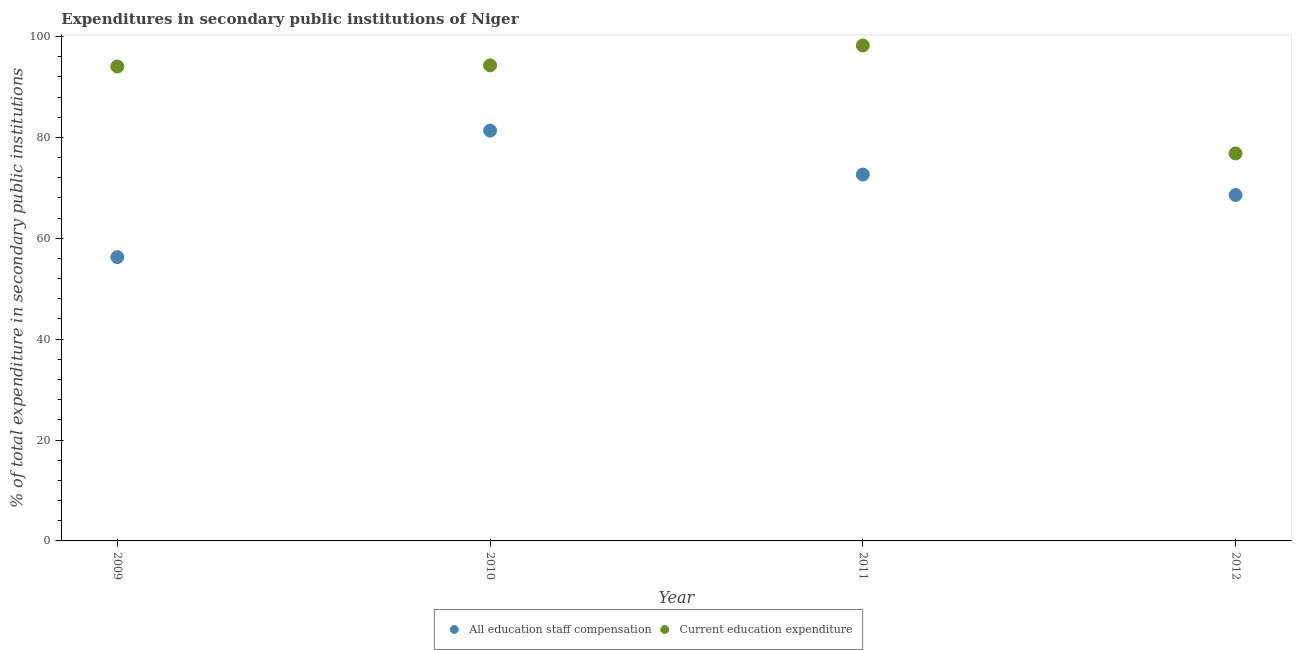How many different coloured dotlines are there?
Offer a terse response. 2. What is the expenditure in education in 2010?
Keep it short and to the point. 94.28. Across all years, what is the maximum expenditure in staff compensation?
Ensure brevity in your answer.  81.35. Across all years, what is the minimum expenditure in education?
Your answer should be compact. 76.82. In which year was the expenditure in education maximum?
Offer a very short reply. 2011. What is the total expenditure in education in the graph?
Ensure brevity in your answer.  363.37. What is the difference between the expenditure in staff compensation in 2009 and that in 2011?
Your answer should be very brief. -16.37. What is the difference between the expenditure in education in 2011 and the expenditure in staff compensation in 2009?
Your answer should be very brief. 41.96. What is the average expenditure in staff compensation per year?
Your answer should be compact. 69.7. In the year 2009, what is the difference between the expenditure in staff compensation and expenditure in education?
Keep it short and to the point. -37.79. In how many years, is the expenditure in education greater than 36 %?
Give a very brief answer. 4. What is the ratio of the expenditure in education in 2011 to that in 2012?
Give a very brief answer. 1.28. Is the expenditure in education in 2009 less than that in 2012?
Your answer should be compact. No. Is the difference between the expenditure in education in 2009 and 2012 greater than the difference between the expenditure in staff compensation in 2009 and 2012?
Make the answer very short. Yes. What is the difference between the highest and the second highest expenditure in education?
Give a very brief answer. 3.94. What is the difference between the highest and the lowest expenditure in education?
Your answer should be very brief. 21.4. In how many years, is the expenditure in staff compensation greater than the average expenditure in staff compensation taken over all years?
Offer a very short reply. 2. Is the sum of the expenditure in education in 2009 and 2011 greater than the maximum expenditure in staff compensation across all years?
Keep it short and to the point. Yes. How many years are there in the graph?
Your answer should be compact. 4. What is the difference between two consecutive major ticks on the Y-axis?
Your answer should be compact. 20. Where does the legend appear in the graph?
Offer a terse response. Bottom center. How many legend labels are there?
Give a very brief answer. 2. How are the legend labels stacked?
Provide a short and direct response. Horizontal. What is the title of the graph?
Your response must be concise. Expenditures in secondary public institutions of Niger. Does "Money lenders" appear as one of the legend labels in the graph?
Keep it short and to the point. No. What is the label or title of the Y-axis?
Offer a terse response. % of total expenditure in secondary public institutions. What is the % of total expenditure in secondary public institutions in All education staff compensation in 2009?
Give a very brief answer. 56.26. What is the % of total expenditure in secondary public institutions in Current education expenditure in 2009?
Provide a short and direct response. 94.05. What is the % of total expenditure in secondary public institutions in All education staff compensation in 2010?
Offer a terse response. 81.35. What is the % of total expenditure in secondary public institutions in Current education expenditure in 2010?
Your answer should be very brief. 94.28. What is the % of total expenditure in secondary public institutions in All education staff compensation in 2011?
Offer a very short reply. 72.63. What is the % of total expenditure in secondary public institutions of Current education expenditure in 2011?
Make the answer very short. 98.22. What is the % of total expenditure in secondary public institutions of All education staff compensation in 2012?
Your answer should be very brief. 68.58. What is the % of total expenditure in secondary public institutions in Current education expenditure in 2012?
Provide a succinct answer. 76.82. Across all years, what is the maximum % of total expenditure in secondary public institutions of All education staff compensation?
Ensure brevity in your answer.  81.35. Across all years, what is the maximum % of total expenditure in secondary public institutions of Current education expenditure?
Offer a very short reply. 98.22. Across all years, what is the minimum % of total expenditure in secondary public institutions of All education staff compensation?
Ensure brevity in your answer.  56.26. Across all years, what is the minimum % of total expenditure in secondary public institutions in Current education expenditure?
Give a very brief answer. 76.82. What is the total % of total expenditure in secondary public institutions in All education staff compensation in the graph?
Make the answer very short. 278.82. What is the total % of total expenditure in secondary public institutions in Current education expenditure in the graph?
Provide a short and direct response. 363.37. What is the difference between the % of total expenditure in secondary public institutions of All education staff compensation in 2009 and that in 2010?
Your answer should be compact. -25.09. What is the difference between the % of total expenditure in secondary public institutions in Current education expenditure in 2009 and that in 2010?
Provide a short and direct response. -0.22. What is the difference between the % of total expenditure in secondary public institutions of All education staff compensation in 2009 and that in 2011?
Make the answer very short. -16.37. What is the difference between the % of total expenditure in secondary public institutions of Current education expenditure in 2009 and that in 2011?
Provide a short and direct response. -4.17. What is the difference between the % of total expenditure in secondary public institutions of All education staff compensation in 2009 and that in 2012?
Provide a short and direct response. -12.32. What is the difference between the % of total expenditure in secondary public institutions of Current education expenditure in 2009 and that in 2012?
Offer a very short reply. 17.24. What is the difference between the % of total expenditure in secondary public institutions of All education staff compensation in 2010 and that in 2011?
Make the answer very short. 8.72. What is the difference between the % of total expenditure in secondary public institutions in Current education expenditure in 2010 and that in 2011?
Offer a very short reply. -3.94. What is the difference between the % of total expenditure in secondary public institutions of All education staff compensation in 2010 and that in 2012?
Keep it short and to the point. 12.77. What is the difference between the % of total expenditure in secondary public institutions in Current education expenditure in 2010 and that in 2012?
Provide a succinct answer. 17.46. What is the difference between the % of total expenditure in secondary public institutions in All education staff compensation in 2011 and that in 2012?
Give a very brief answer. 4.05. What is the difference between the % of total expenditure in secondary public institutions of Current education expenditure in 2011 and that in 2012?
Provide a succinct answer. 21.4. What is the difference between the % of total expenditure in secondary public institutions in All education staff compensation in 2009 and the % of total expenditure in secondary public institutions in Current education expenditure in 2010?
Ensure brevity in your answer.  -38.02. What is the difference between the % of total expenditure in secondary public institutions in All education staff compensation in 2009 and the % of total expenditure in secondary public institutions in Current education expenditure in 2011?
Keep it short and to the point. -41.96. What is the difference between the % of total expenditure in secondary public institutions in All education staff compensation in 2009 and the % of total expenditure in secondary public institutions in Current education expenditure in 2012?
Give a very brief answer. -20.56. What is the difference between the % of total expenditure in secondary public institutions of All education staff compensation in 2010 and the % of total expenditure in secondary public institutions of Current education expenditure in 2011?
Keep it short and to the point. -16.87. What is the difference between the % of total expenditure in secondary public institutions in All education staff compensation in 2010 and the % of total expenditure in secondary public institutions in Current education expenditure in 2012?
Your response must be concise. 4.53. What is the difference between the % of total expenditure in secondary public institutions of All education staff compensation in 2011 and the % of total expenditure in secondary public institutions of Current education expenditure in 2012?
Keep it short and to the point. -4.19. What is the average % of total expenditure in secondary public institutions in All education staff compensation per year?
Your answer should be compact. 69.7. What is the average % of total expenditure in secondary public institutions of Current education expenditure per year?
Make the answer very short. 90.84. In the year 2009, what is the difference between the % of total expenditure in secondary public institutions of All education staff compensation and % of total expenditure in secondary public institutions of Current education expenditure?
Provide a short and direct response. -37.79. In the year 2010, what is the difference between the % of total expenditure in secondary public institutions of All education staff compensation and % of total expenditure in secondary public institutions of Current education expenditure?
Your answer should be very brief. -12.93. In the year 2011, what is the difference between the % of total expenditure in secondary public institutions of All education staff compensation and % of total expenditure in secondary public institutions of Current education expenditure?
Your answer should be very brief. -25.59. In the year 2012, what is the difference between the % of total expenditure in secondary public institutions in All education staff compensation and % of total expenditure in secondary public institutions in Current education expenditure?
Your answer should be compact. -8.24. What is the ratio of the % of total expenditure in secondary public institutions of All education staff compensation in 2009 to that in 2010?
Give a very brief answer. 0.69. What is the ratio of the % of total expenditure in secondary public institutions of Current education expenditure in 2009 to that in 2010?
Your answer should be compact. 1. What is the ratio of the % of total expenditure in secondary public institutions in All education staff compensation in 2009 to that in 2011?
Offer a terse response. 0.77. What is the ratio of the % of total expenditure in secondary public institutions of Current education expenditure in 2009 to that in 2011?
Make the answer very short. 0.96. What is the ratio of the % of total expenditure in secondary public institutions of All education staff compensation in 2009 to that in 2012?
Make the answer very short. 0.82. What is the ratio of the % of total expenditure in secondary public institutions of Current education expenditure in 2009 to that in 2012?
Make the answer very short. 1.22. What is the ratio of the % of total expenditure in secondary public institutions of All education staff compensation in 2010 to that in 2011?
Make the answer very short. 1.12. What is the ratio of the % of total expenditure in secondary public institutions of Current education expenditure in 2010 to that in 2011?
Offer a very short reply. 0.96. What is the ratio of the % of total expenditure in secondary public institutions in All education staff compensation in 2010 to that in 2012?
Your answer should be compact. 1.19. What is the ratio of the % of total expenditure in secondary public institutions in Current education expenditure in 2010 to that in 2012?
Your answer should be very brief. 1.23. What is the ratio of the % of total expenditure in secondary public institutions in All education staff compensation in 2011 to that in 2012?
Your answer should be compact. 1.06. What is the ratio of the % of total expenditure in secondary public institutions of Current education expenditure in 2011 to that in 2012?
Your response must be concise. 1.28. What is the difference between the highest and the second highest % of total expenditure in secondary public institutions of All education staff compensation?
Ensure brevity in your answer.  8.72. What is the difference between the highest and the second highest % of total expenditure in secondary public institutions of Current education expenditure?
Ensure brevity in your answer.  3.94. What is the difference between the highest and the lowest % of total expenditure in secondary public institutions of All education staff compensation?
Your answer should be compact. 25.09. What is the difference between the highest and the lowest % of total expenditure in secondary public institutions of Current education expenditure?
Your answer should be very brief. 21.4. 